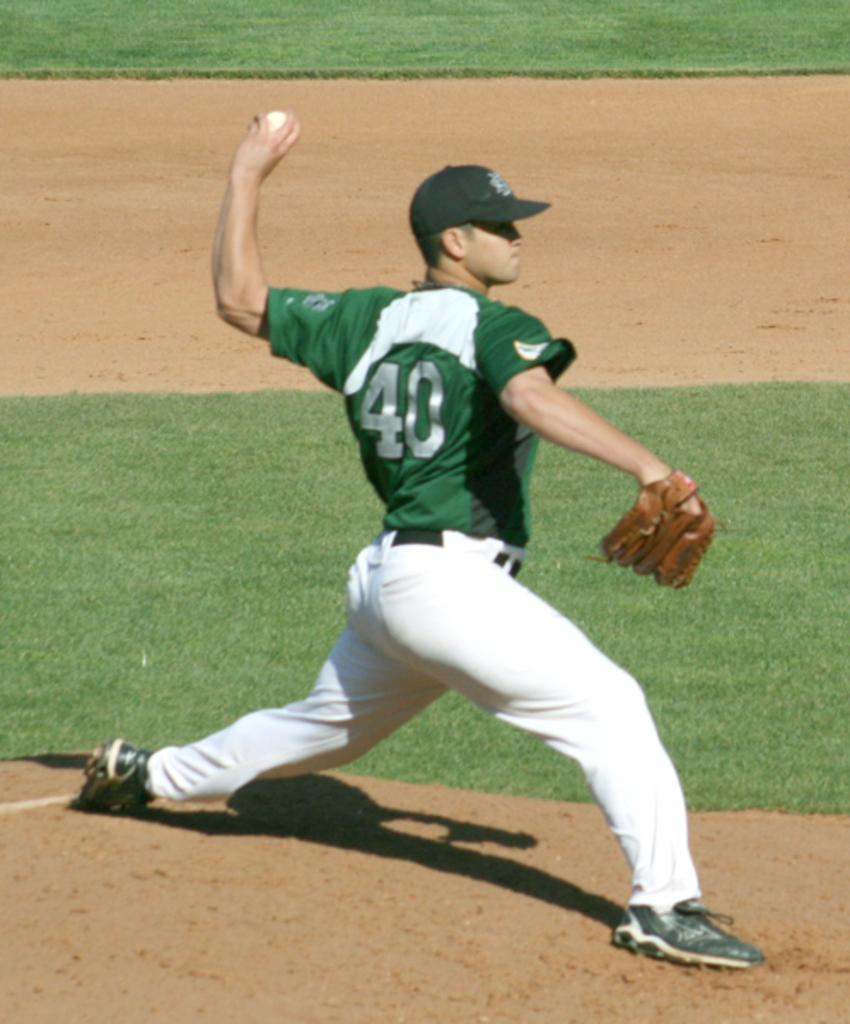Provide a one-sentence caption for the provided image. A baseball player wearing jersey number 40 is pitching the ball. 